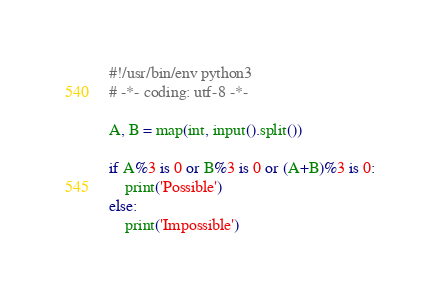Convert code to text. <code><loc_0><loc_0><loc_500><loc_500><_Python_>#!/usr/bin/env python3
# -*- coding: utf-8 -*-

A, B = map(int, input().split())

if A%3 is 0 or B%3 is 0 or (A+B)%3 is 0:
    print('Possible')
else:
    print('Impossible')
</code> 